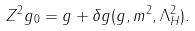Convert formula to latex. <formula><loc_0><loc_0><loc_500><loc_500>Z ^ { 2 } g _ { 0 } = g + \delta g ( g , m ^ { 2 } , \Lambda _ { H } ^ { 2 } ) .</formula> 